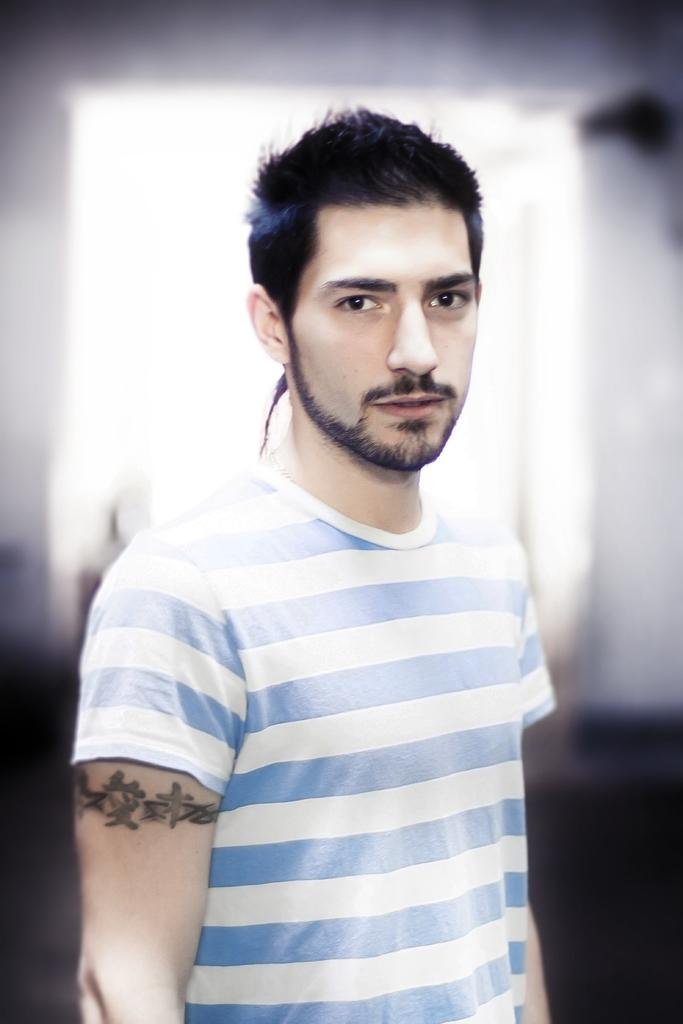What is the main subject of the image? There is a man in the image. What is the man doing in the image? The man is standing in the image. What is the man wearing in the image? The man is wearing a blue and white t-shirt in the image. Can you describe any additional features of the man? The man has a tattoo on his hand in the image. What type of suggestion can be seen written on the man's arm in the image? There is no suggestion written on the man's arm in the image. Is there any snow visible in the image? There is no snow present in the image. 